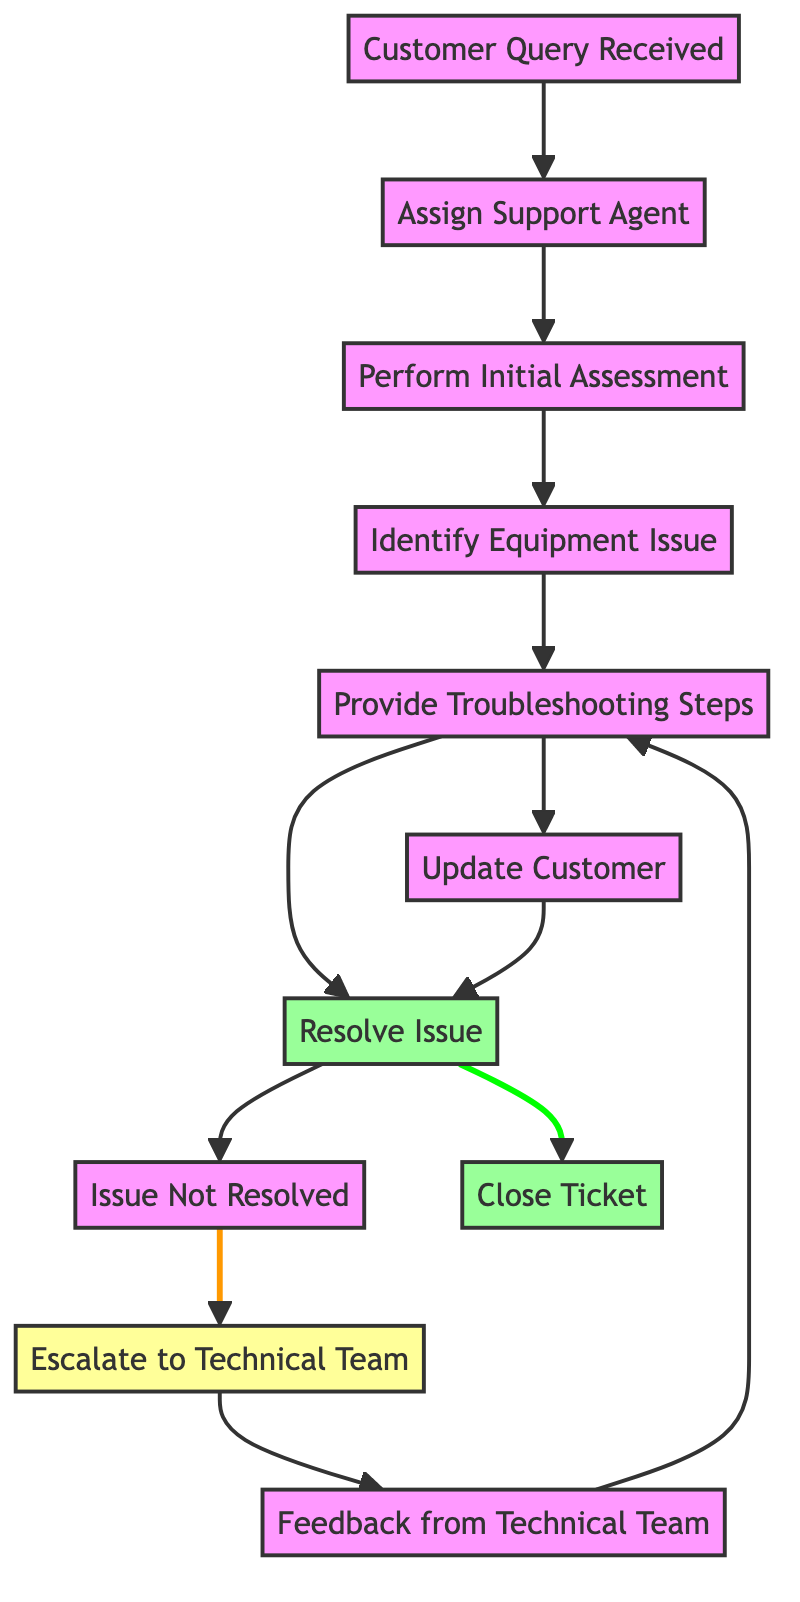What is the first step after receiving a customer query? The diagram indicates that the first action following a customer query is to "Assign Support Agent". This is the direct next step linked from the node "Customer Query Received".
Answer: Assign Support Agent How many nodes are present in the diagram? By counting the nodes listed in the data, there are a total of 11 nodes representing various steps in the workflow.
Answer: 11 What happens if the issue is not resolved? According to the diagram, if the issue is not resolved, the next step is to "Escalate to Technical Team". This node follows the "Issue Not Resolved" node.
Answer: Escalate to Technical Team Which node follows "Provide Troubleshooting Steps"? The diagram shows that the node "Resolve Issue" follows "Provide Troubleshooting Steps". This is a direct link from one node to the next.
Answer: Resolve Issue How many edges are in the diagram? By counting the connections (edges) between the nodes in the data, there are 12 edges that depict the workflow between the different steps.
Answer: 12 What feedback is received after escalating to the technical team? The next step after escalating to the technical team is to receive "Feedback from Technical Team", which directly follows the escalation step in the diagram.
Answer: Feedback from Technical Team What happens after providing troubleshooting steps if the issue is unresolved? The diagram indicates that if the issue is unresolved, the troubleshooting steps may need to be repeated after receiving feedback from the technical team, linking back to "Provide Troubleshooting Steps".
Answer: Provide Troubleshooting Steps Which node shows the final outcome of the support workflow? The diagram indicates that "Close Ticket" is the final node in the successful resolution of the support workflow. It signifies the completion of the customer's issue handling.
Answer: Close Ticket What action is taken after the customer is updated? The next action after "Update Customer" is to go back to "Resolve Issue", indicating that the workflow may loop until resolution is achieved.
Answer: Resolve Issue 